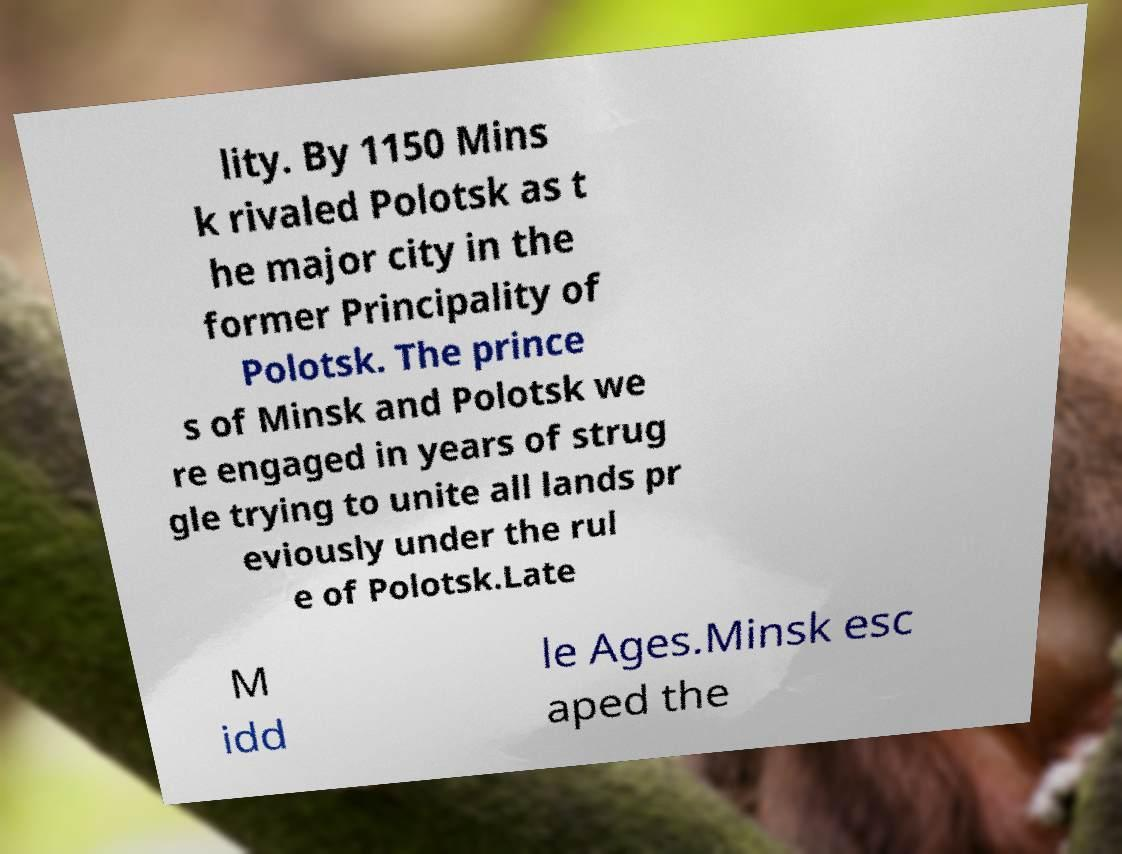Please identify and transcribe the text found in this image. lity. By 1150 Mins k rivaled Polotsk as t he major city in the former Principality of Polotsk. The prince s of Minsk and Polotsk we re engaged in years of strug gle trying to unite all lands pr eviously under the rul e of Polotsk.Late M idd le Ages.Minsk esc aped the 